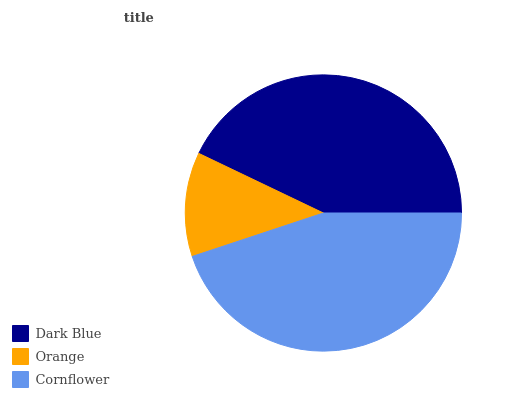Is Orange the minimum?
Answer yes or no. Yes. Is Cornflower the maximum?
Answer yes or no. Yes. Is Cornflower the minimum?
Answer yes or no. No. Is Orange the maximum?
Answer yes or no. No. Is Cornflower greater than Orange?
Answer yes or no. Yes. Is Orange less than Cornflower?
Answer yes or no. Yes. Is Orange greater than Cornflower?
Answer yes or no. No. Is Cornflower less than Orange?
Answer yes or no. No. Is Dark Blue the high median?
Answer yes or no. Yes. Is Dark Blue the low median?
Answer yes or no. Yes. Is Orange the high median?
Answer yes or no. No. Is Orange the low median?
Answer yes or no. No. 